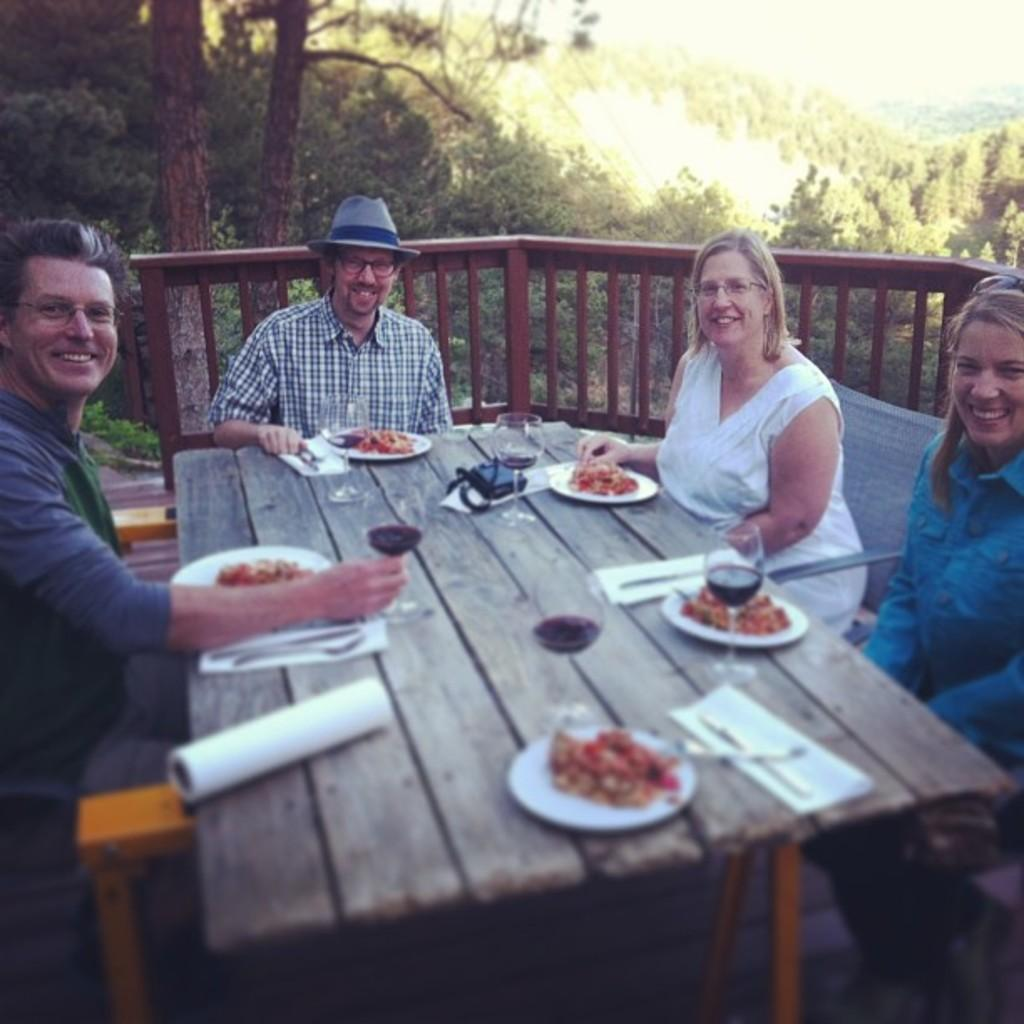How many people are present in the image? There are four people in the image, two men and two women. What is on the table in the image? There is a table with food on it in the image. What can be seen in the background of the image? There are trees in the background of the image. What might be used for drinking in the image? There are glasses on the table in the image. What reason do the girls have for being in the image? There are no girls present in the image; it features two men and two women. 